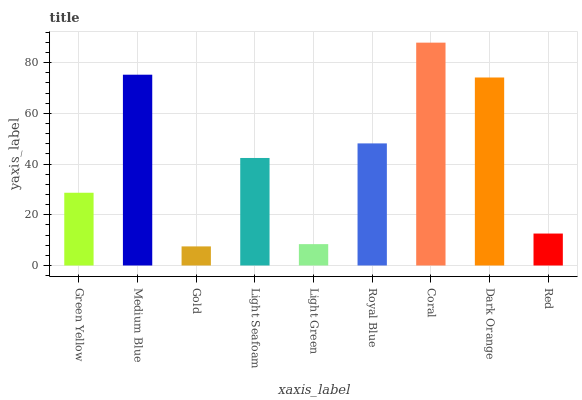Is Medium Blue the minimum?
Answer yes or no. No. Is Medium Blue the maximum?
Answer yes or no. No. Is Medium Blue greater than Green Yellow?
Answer yes or no. Yes. Is Green Yellow less than Medium Blue?
Answer yes or no. Yes. Is Green Yellow greater than Medium Blue?
Answer yes or no. No. Is Medium Blue less than Green Yellow?
Answer yes or no. No. Is Light Seafoam the high median?
Answer yes or no. Yes. Is Light Seafoam the low median?
Answer yes or no. Yes. Is Green Yellow the high median?
Answer yes or no. No. Is Gold the low median?
Answer yes or no. No. 